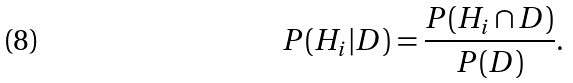Convert formula to latex. <formula><loc_0><loc_0><loc_500><loc_500>P ( H _ { i } | D ) = \frac { P ( H _ { i } \cap D ) } { P ( D ) } .</formula> 